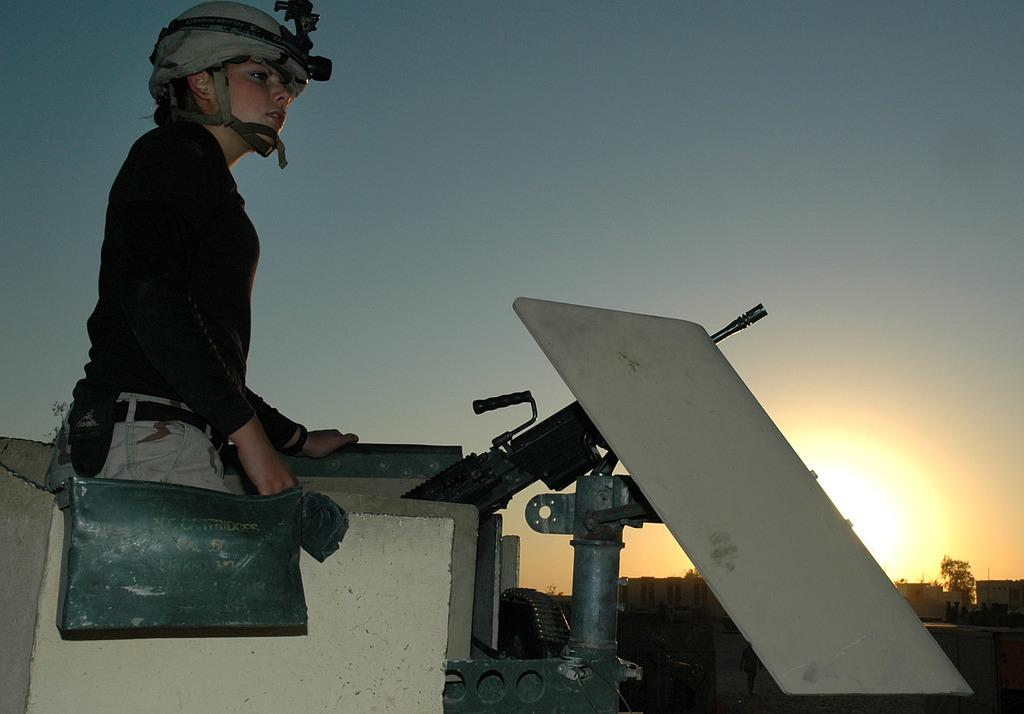Who is present in the image? There is a woman in the image. What is the woman wearing on her head? The woman is wearing a helmet. What is the woman carrying on her body? The woman is wearing a bag. What can be seen in front of the woman? There is a gun on a pole in front of the woman. What is visible in the background of the image? There is a sunrise and the sky in the background of the image. How does the wire feel in the image? There is no wire present in the image, so it cannot be felt or described. 